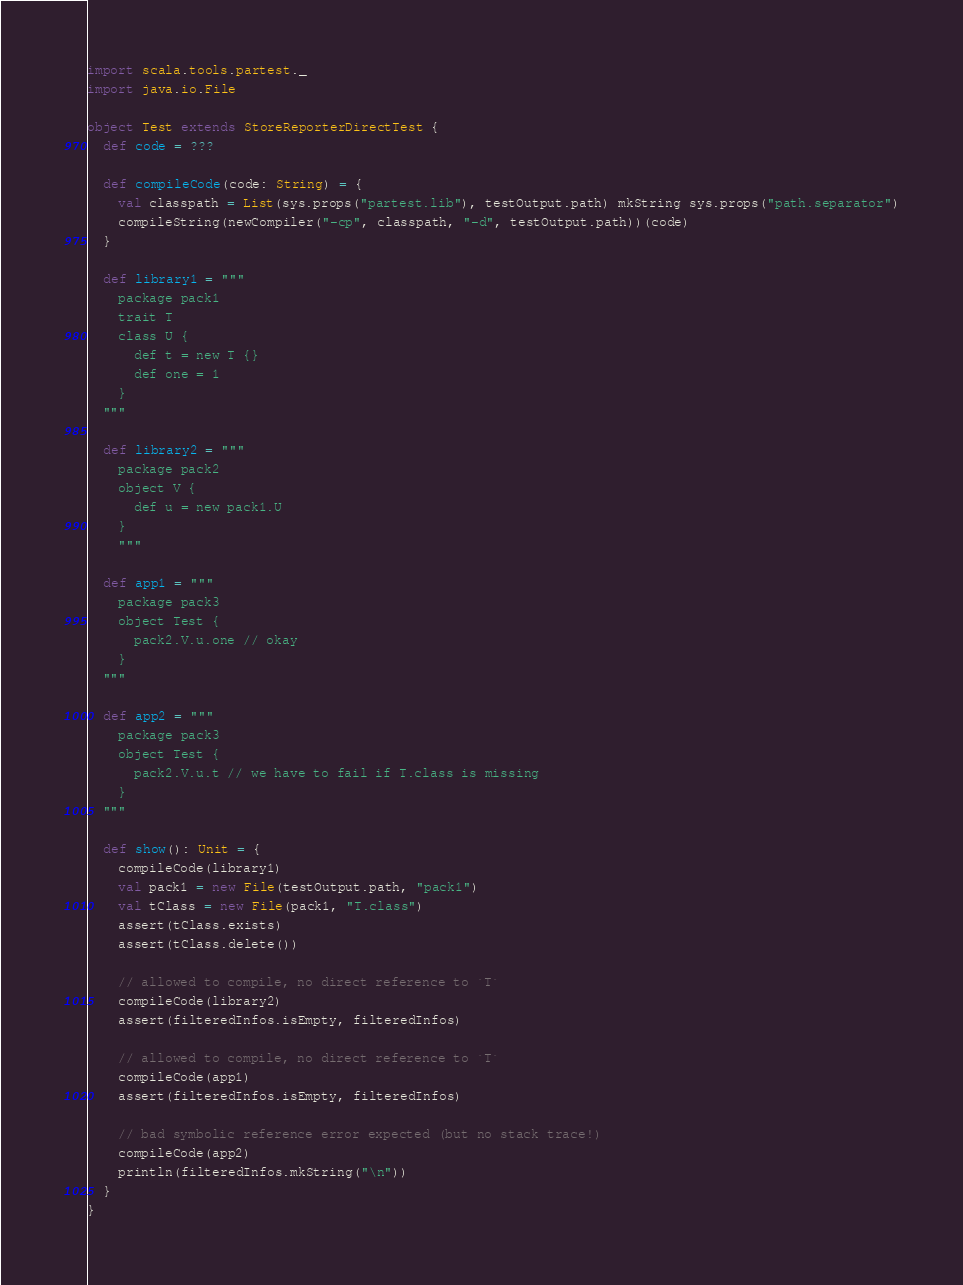<code> <loc_0><loc_0><loc_500><loc_500><_Scala_>import scala.tools.partest._
import java.io.File

object Test extends StoreReporterDirectTest {
  def code = ???

  def compileCode(code: String) = {
    val classpath = List(sys.props("partest.lib"), testOutput.path) mkString sys.props("path.separator")
    compileString(newCompiler("-cp", classpath, "-d", testOutput.path))(code)
  }

  def library1 = """
    package pack1
    trait T
    class U {
      def t = new T {}
      def one = 1
    }
  """

  def library2 = """
    package pack2
    object V {
      def u = new pack1.U
    }
    """

  def app1 = """
    package pack3
    object Test {
      pack2.V.u.one // okay
    }
  """

  def app2 = """
    package pack3
    object Test {
      pack2.V.u.t // we have to fail if T.class is missing
    }
  """

  def show(): Unit = {
    compileCode(library1)
    val pack1 = new File(testOutput.path, "pack1")
    val tClass = new File(pack1, "T.class")
    assert(tClass.exists)
    assert(tClass.delete())

    // allowed to compile, no direct reference to `T`
    compileCode(library2)
    assert(filteredInfos.isEmpty, filteredInfos)

    // allowed to compile, no direct reference to `T`
    compileCode(app1)
    assert(filteredInfos.isEmpty, filteredInfos)

    // bad symbolic reference error expected (but no stack trace!)
    compileCode(app2)
    println(filteredInfos.mkString("\n"))
  }
}
</code> 